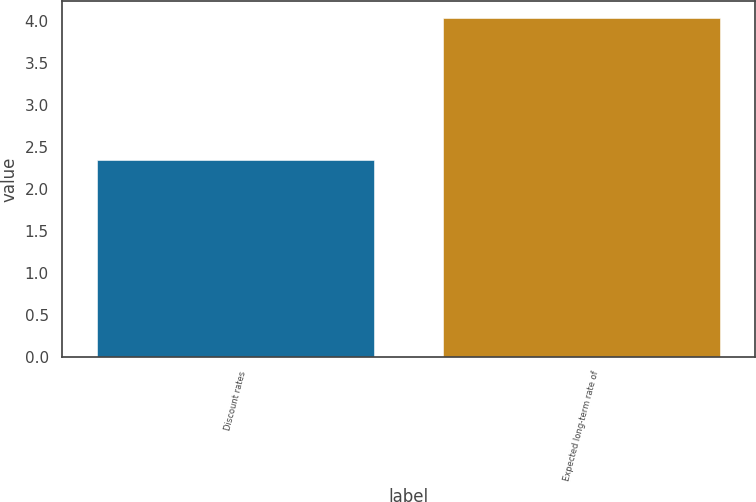<chart> <loc_0><loc_0><loc_500><loc_500><bar_chart><fcel>Discount rates<fcel>Expected long-term rate of<nl><fcel>2.34<fcel>4.03<nl></chart> 